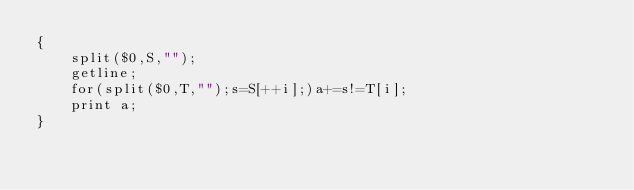<code> <loc_0><loc_0><loc_500><loc_500><_Awk_>{
    split($0,S,"");
    getline;
    for(split($0,T,"");s=S[++i];)a+=s!=T[i];
    print a;
}</code> 